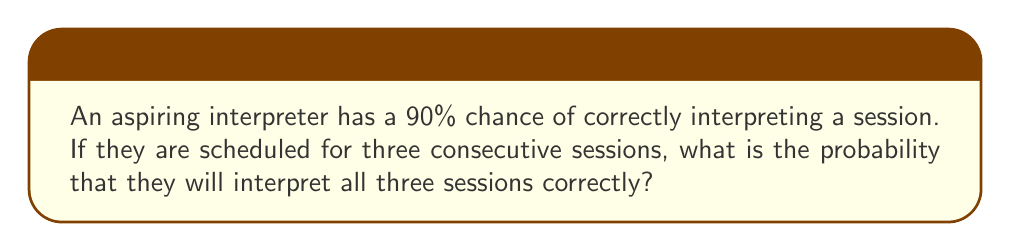Give your solution to this math problem. Let's approach this step-by-step:

1) The probability of correctly interpreting a single session is 90% or 0.9.

2) We need to calculate the probability of correctly interpreting all three sessions. This means the interpreter needs to be successful in the first AND second AND third session.

3) In probability theory, when we have independent events that all need to occur, we multiply the individual probabilities.

4) Let's define the event of correctly interpreting a session as $A$. Then:

   $P(A) = 0.9$

5) We want to find $P(A \text{ and } A \text{ and } A)$, which can be written as $P(A \cap A \cap A)$ or $P(A)^3$.

6) Therefore, the probability of correctly interpreting all three sessions is:

   $$P(A)^3 = 0.9^3 = 0.729$$

7) To convert to a percentage, we multiply by 100:

   $0.729 \times 100 = 72.9\%$

Thus, the probability of correctly interpreting all three consecutive sessions is 72.9%.
Answer: 72.9% 